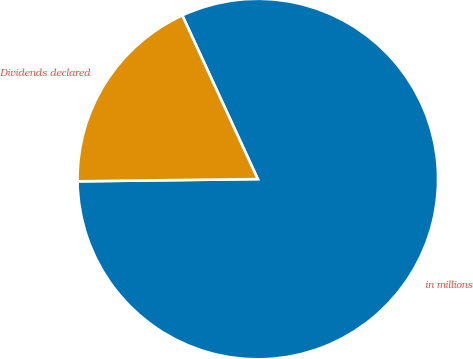<chart> <loc_0><loc_0><loc_500><loc_500><pie_chart><fcel>in millions<fcel>Dividends declared<nl><fcel>81.68%<fcel>18.32%<nl></chart> 